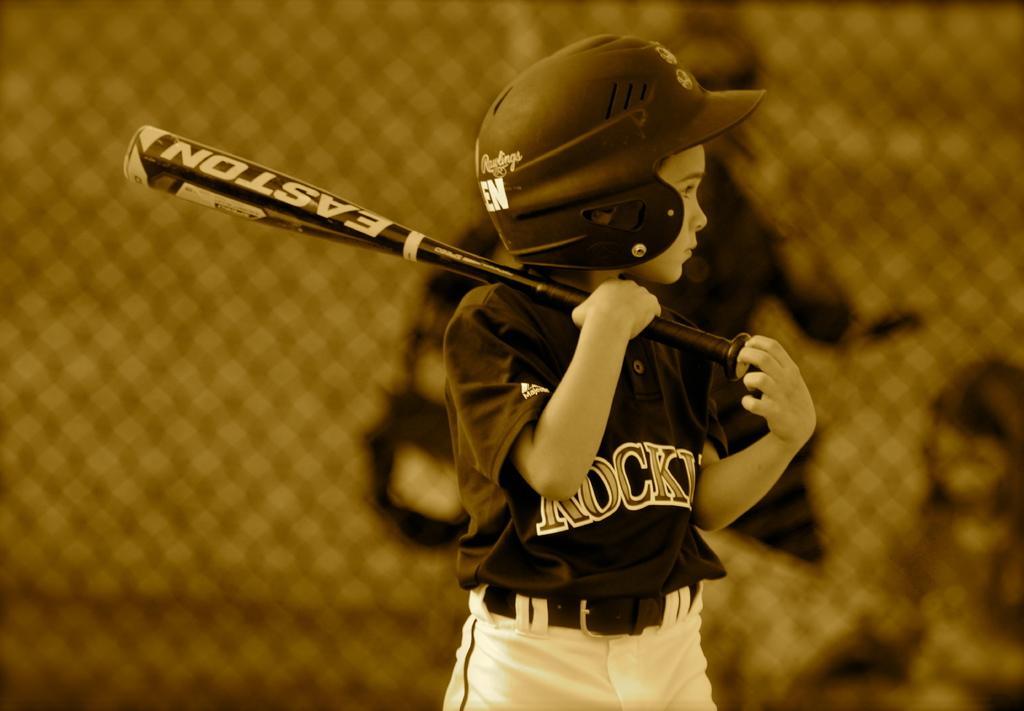Describe this image in one or two sentences. A person is standing wearing a helmet, t shirt and holding a baseball bat in his hand. Behind him there is a fencing. 